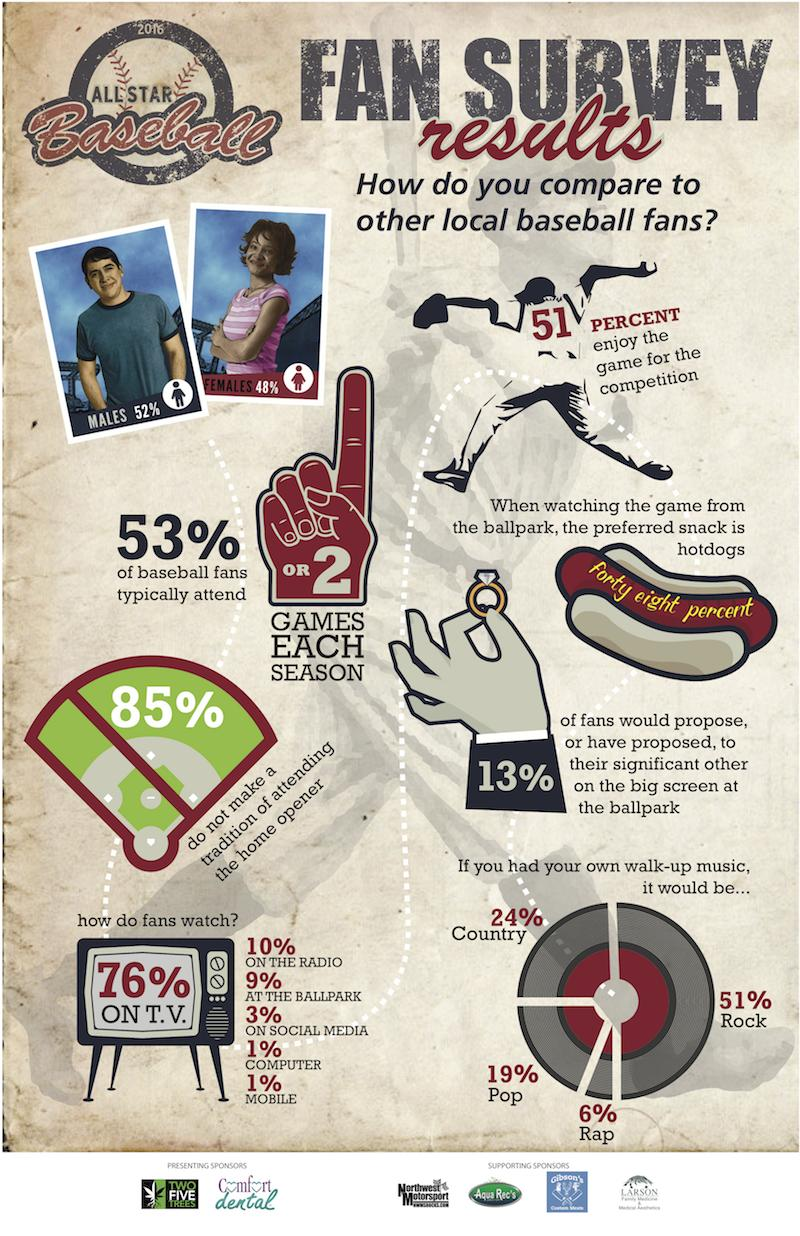Point out several critical features in this image. According to a recent survey, a staggering 97% of baseball fans are watching the sport not on social media. It is estimated that a vast majority of baseball fans, approximately 99%, do not watch the sport on a computer. A significant percentage of baseball fans are watching the sport not on a TV, with 24% of fans choosing to watch in person or on a computer screen. I can confidently assert that a staggering 99% of baseball fans are choosing to watch the sport on traditional television rather than their mobile devices. According to recent statistics, a staggering 91% of baseball fans are watching the sport not at the ballpark. This is a clear indication that the popularity of baseball extends far beyond the confines of the stadium and into the homes and living rooms of fans across the country. 